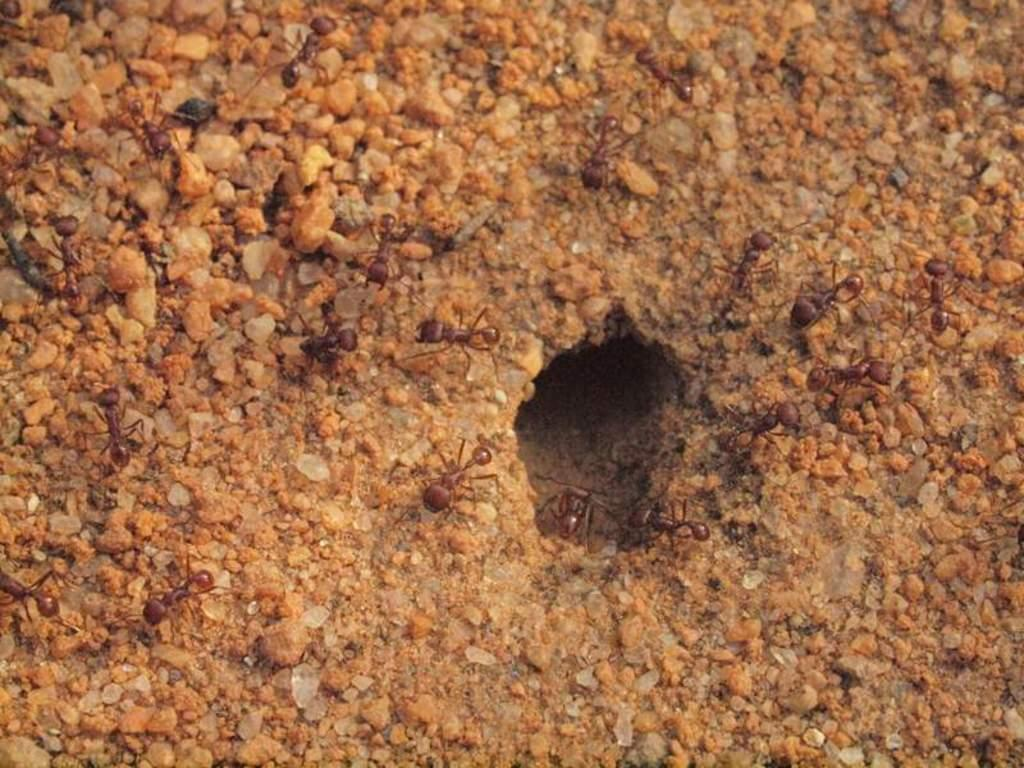What type of insects can be seen in the image? There are ants in the image. What color are the ants? The ants are red in color. What is the main feature in the middle of the image? There is a hole in the middle of the image. What can be seen in the background of the image? Small stones are visible in the background of the image. Can you tell me how many spoons are being used by the ants in the image? There are no spoons present in the image; it features red ants and a hole in the middle of the image. Is there a sofa visible in the image? There is no sofa present in the image. 